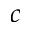<formula> <loc_0><loc_0><loc_500><loc_500>c</formula> 